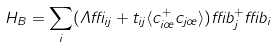Convert formula to latex. <formula><loc_0><loc_0><loc_500><loc_500>H _ { B } = \sum _ { i } ( \Lambda \delta _ { i j } + t _ { i j } \langle c ^ { + } _ { i \sigma } c _ { j \sigma } \rangle ) \delta b ^ { + } _ { j } \delta b _ { i }</formula> 